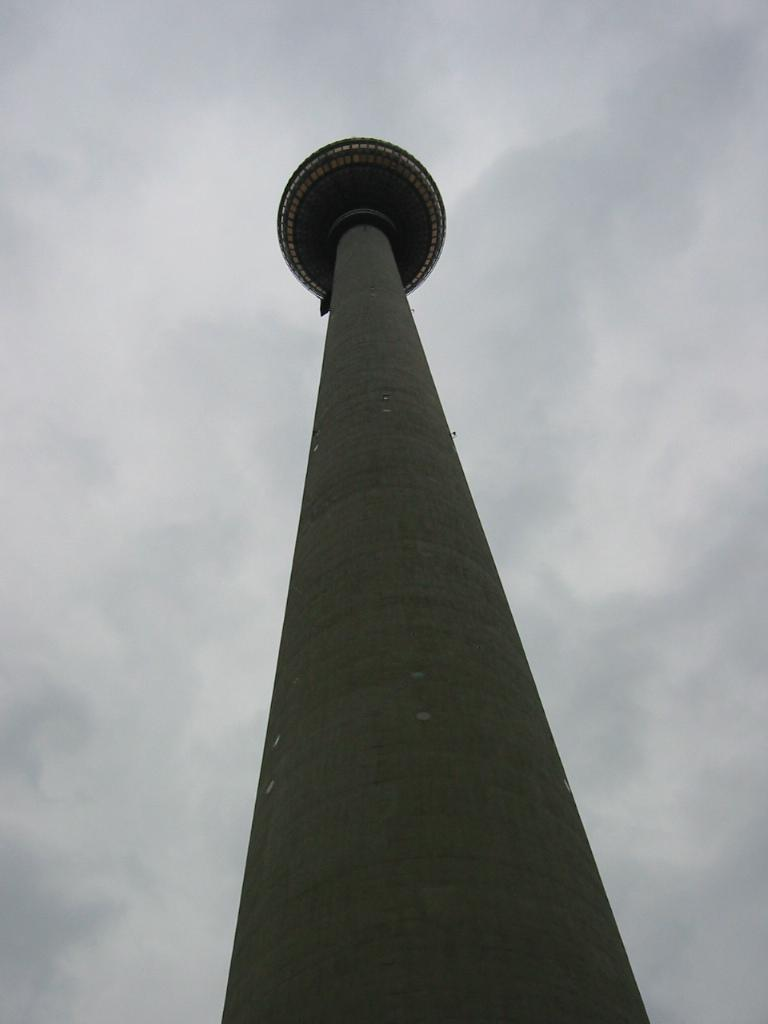What is the main structure in the middle of the image? There is a tower in the middle of the image. What can be seen in the sky in the background of the image? There are clouds in the sky in the background of the image. What type of quilt is being used to cover the tower in the image? There is no quilt present in the image; it features a tower and clouds in the sky. How many stars can be seen on the tower in the image? There are no stars visible on the tower in the image. 